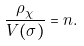<formula> <loc_0><loc_0><loc_500><loc_500>\frac { \rho _ { \chi } } { V ( \sigma ) } = n .</formula> 